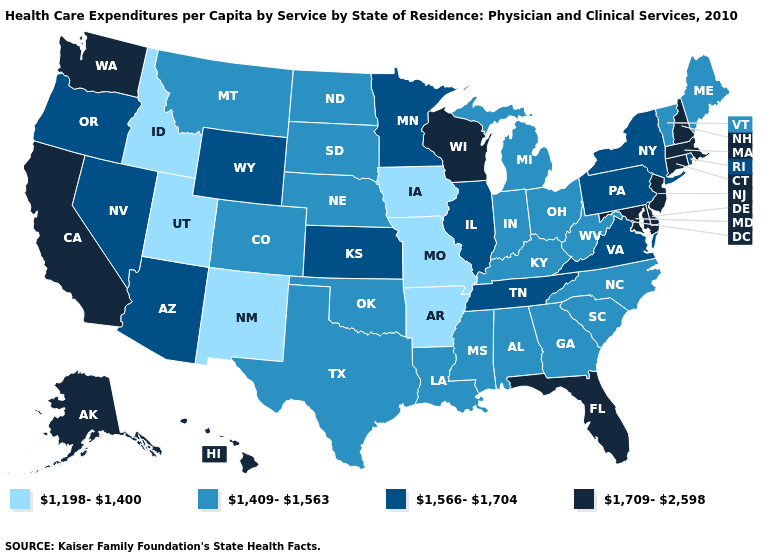Among the states that border Iowa , which have the lowest value?
Short answer required. Missouri. Does Maryland have a higher value than Nebraska?
Give a very brief answer. Yes. What is the value of Missouri?
Write a very short answer. 1,198-1,400. Which states hav the highest value in the MidWest?
Write a very short answer. Wisconsin. Does the map have missing data?
Give a very brief answer. No. What is the lowest value in states that border Utah?
Keep it brief. 1,198-1,400. What is the value of New Jersey?
Give a very brief answer. 1,709-2,598. What is the lowest value in the Northeast?
Short answer required. 1,409-1,563. What is the value of Washington?
Answer briefly. 1,709-2,598. Does Virginia have the lowest value in the USA?
Give a very brief answer. No. Which states have the lowest value in the South?
Short answer required. Arkansas. What is the value of Rhode Island?
Quick response, please. 1,566-1,704. What is the value of North Dakota?
Keep it brief. 1,409-1,563. Among the states that border Texas , which have the highest value?
Give a very brief answer. Louisiana, Oklahoma. 